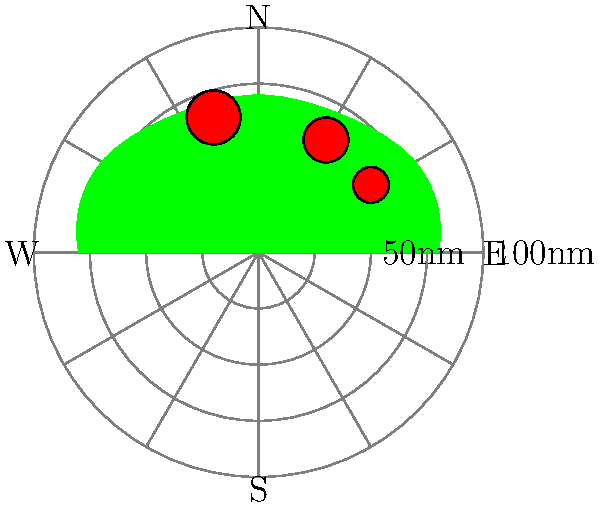As a safety-conscious sailor, you're examining a marine weather radar image before setting out. The image shows three distinct storm cells near a coastline. What is the approximate bearing and distance of the largest storm cell from your current position at the center of the radar? To determine the bearing and distance of the largest storm cell:

1. Identify the largest storm cell:
   The largest red circle on the image represents the largest storm cell, located in the upper-left quadrant.

2. Estimate the bearing:
   - The radar is divided into 30-degree increments.
   - The storm cell is between the 300° and 330° radial lines.
   - It appears to be closer to the 330° line, so we can estimate it at about 320°.
   - 320° corresponds to a bearing of North-Northwest (NNW).

3. Estimate the distance:
   - The radar has concentric circles at 25nm intervals.
   - The storm cell is between the second (50nm) and third (75nm) circles.
   - It's slightly closer to the 75nm circle, so we can estimate it at about 60 nautical miles.

4. Combine the bearing and distance:
   The largest storm cell is approximately 320° (NNW) at 60 nautical miles from your position.
Answer: 320° (NNW), 60 nautical miles 